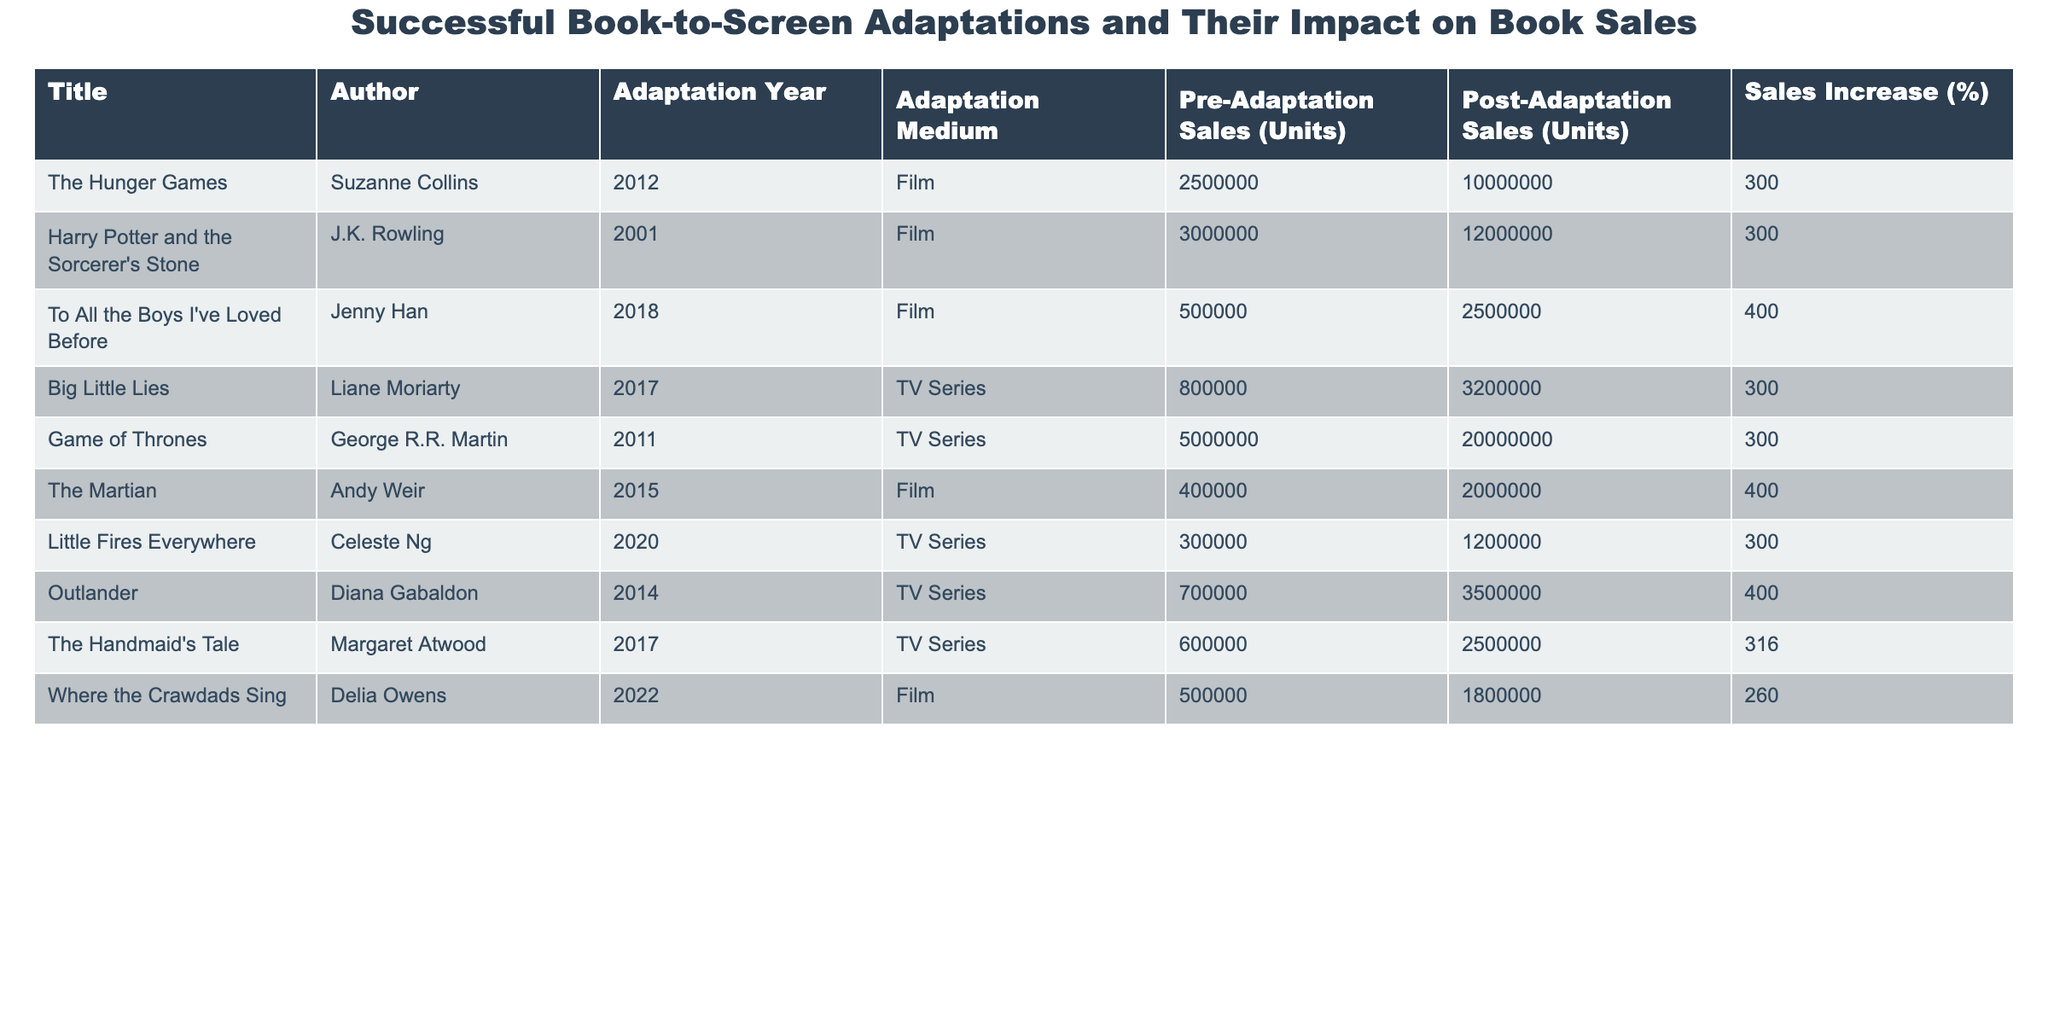What is the adaptation medium for "The Martian"? Referring to the table, under the column "Adaptation Medium," we can see that "The Martian" was adapted into a "Film."
Answer: Film Which book had the highest pre-adaptation sales? Looking at the "Pre-Adaptation Sales (Units)" column, "Game of Thrones" has the highest number of units sold at 5,000,000.
Answer: Game of Thrones How many units did "To All the Boys I've Loved Before" sell post-adaptation? The "Post-Adaptation Sales (Units)" column shows that "To All the Boys I've Loved Before" sold 2,500,000 units after its adaptation.
Answer: 2,500,000 What is the average percentage increase in sales across all titles? To find the average, we sum the "Sales Increase (%)" values (300 + 300 + 400 + 300 + 300 + 400 + 300 + 400 + 316 + 260) = 3,076, and divide by the total number of titles (10), which gives us 3,076 / 10 = 307.6.
Answer: 307.6 Did "Harry Potter and the Sorcerer's Stone" see a greater or lesser increase in sales percentage compared to "Little Fires Everywhere"? "Harry Potter and the Sorcerer's Stone" has a sales increase of 300%, while "Little Fires Everywhere" has 300%, which means they are equal.
Answer: Equal Which adaptation resulted in the highest sales increase percentage and what was that percentage? Checking the "Sales Increase (%)" column, "To All the Boys I've Loved Before" and "The Martian" both have the highest increase at 400%.
Answer: 400% Which author had the most units sold post-adaptation? By examining the "Post-Adaptation Sales (Units)," "Game of Thrones" leads with 20,000,000 units sold post-adaptation.
Answer: George R.R. Martin How many total units were sold across all titles before adaptation? Summing the "Pre-Adaptation Sales (Units)" gives (2,500,000 + 3,000,000 + 500,000 + 800,000 + 5,000,000 + 400,000 + 300,000 + 700,000 + 600,000 + 500,000) = 14,000,000 units sold before adaptation.
Answer: 14,000,000 Is it true that all adaptations listed saw an increase in sales? By checking the "Sales Increase (%)" for each title, we see all are above 250%, confirming that every title had an increase in sales.
Answer: True What is the difference in post-adaptation sales between "Where the Crawdads Sing" and "Big Little Lies"? From the table, "Where the Crawdads Sing" sold 1,800,000 units post-adaptation, while "Big Little Lies" sold 3,200,000 units. The difference is 3,200,000 - 1,800,000 = 1,400,000 units.
Answer: 1,400,000 